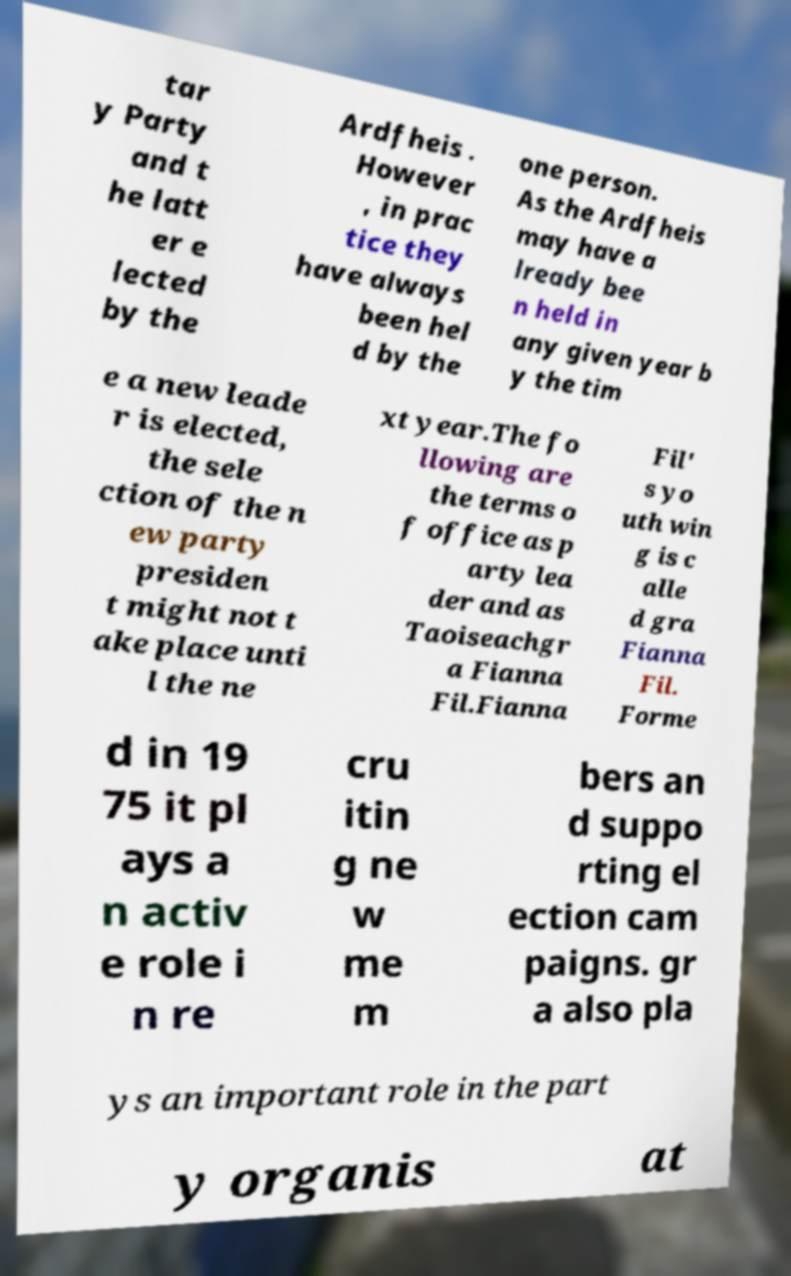For documentation purposes, I need the text within this image transcribed. Could you provide that? tar y Party and t he latt er e lected by the Ardfheis . However , in prac tice they have always been hel d by the one person. As the Ardfheis may have a lready bee n held in any given year b y the tim e a new leade r is elected, the sele ction of the n ew party presiden t might not t ake place unti l the ne xt year.The fo llowing are the terms o f office as p arty lea der and as Taoiseachgr a Fianna Fil.Fianna Fil' s yo uth win g is c alle d gra Fianna Fil. Forme d in 19 75 it pl ays a n activ e role i n re cru itin g ne w me m bers an d suppo rting el ection cam paigns. gr a also pla ys an important role in the part y organis at 